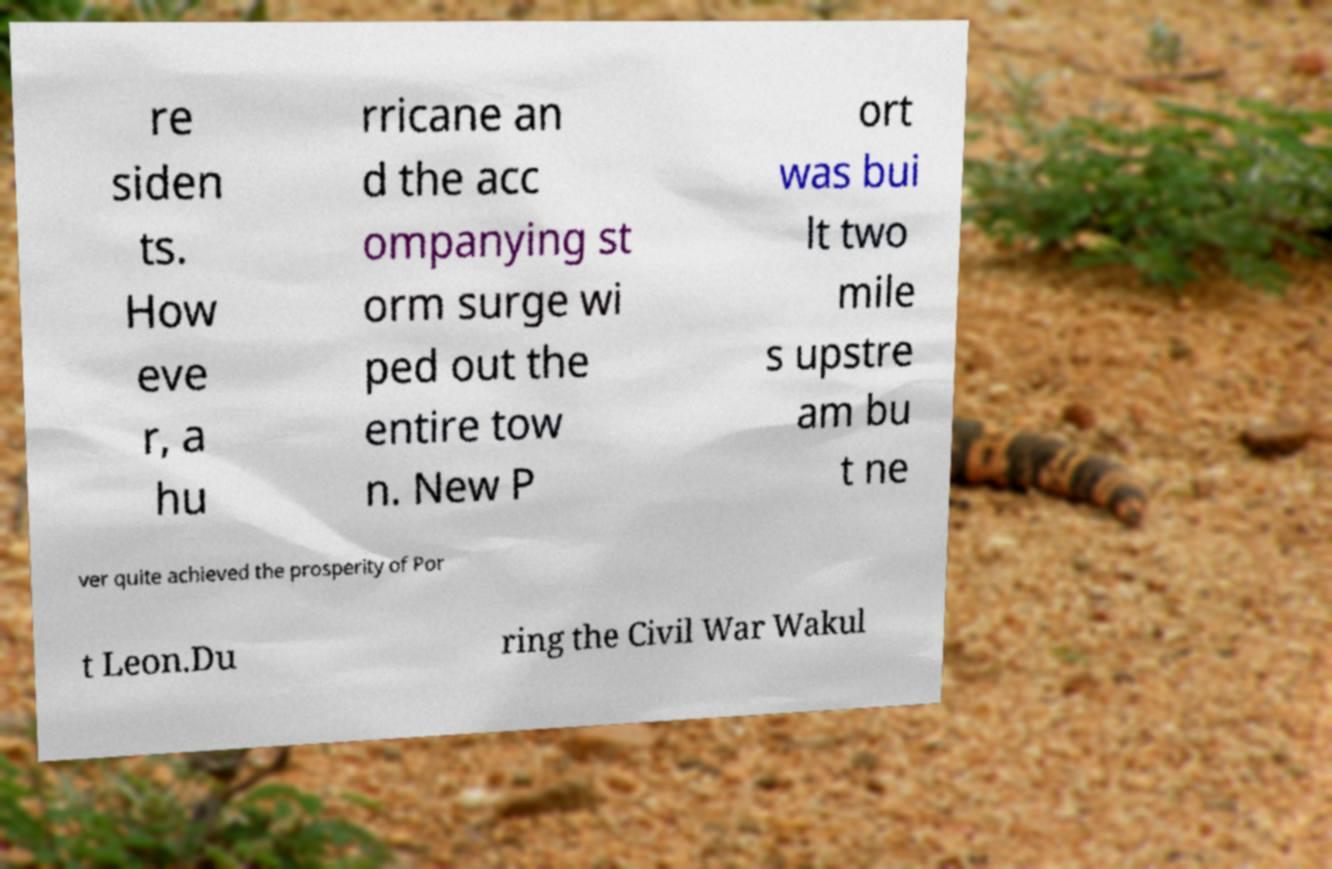Could you extract and type out the text from this image? re siden ts. How eve r, a hu rricane an d the acc ompanying st orm surge wi ped out the entire tow n. New P ort was bui lt two mile s upstre am bu t ne ver quite achieved the prosperity of Por t Leon.Du ring the Civil War Wakul 